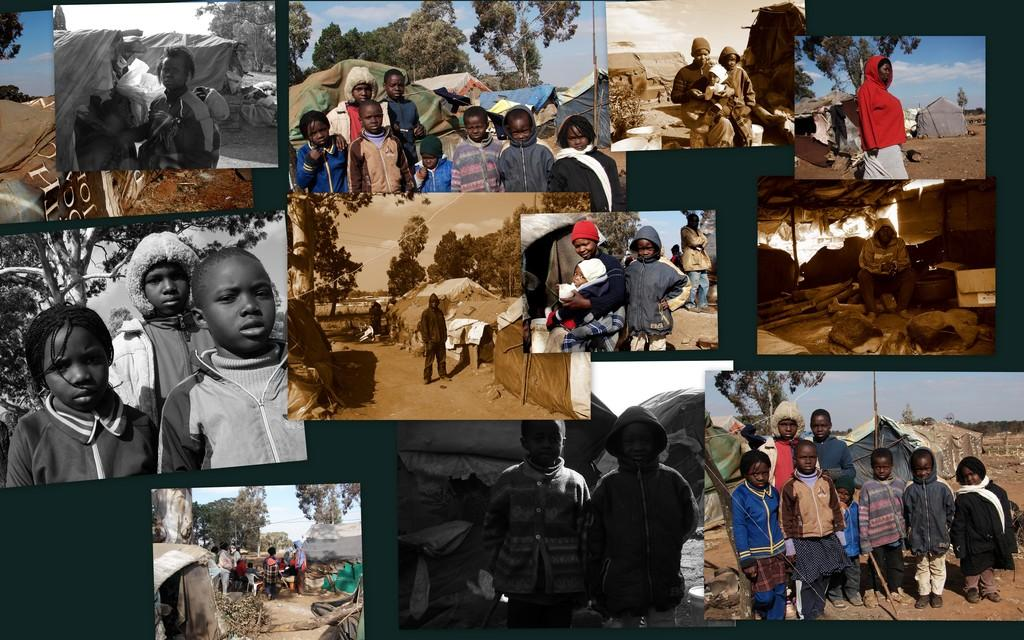What type of artwork is the image? The image is a collage. What can be seen in the individual pictures within the collage? There are people standing in the pictures. What type of food is present in the image? There are nuts in the image. What type of natural environment is depicted in the image? There are trees in the image. Can you see any wire fences in the image? There is no wire fence present in the image. Is there a field visible in the image? There is no field visible in the image. 